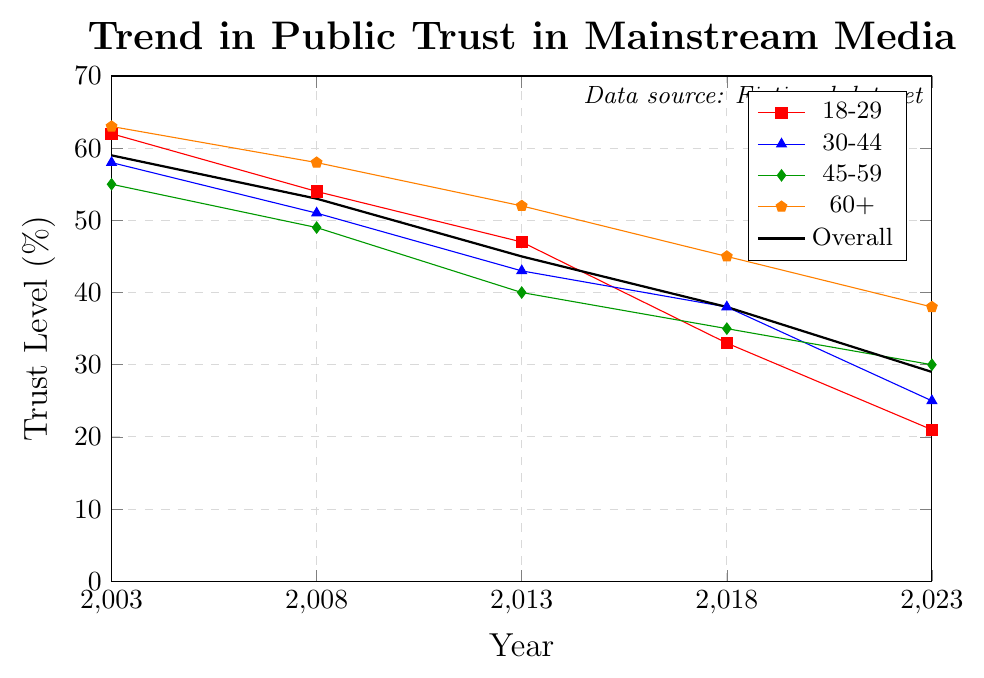What's the trend in public trust in mainstream media among the 18-29 age group over the past two decades? From the figure, we see the trust level for the 18-29 age group. It starts at 62% in 2003, drops to 54% in 2008, further to 47% in 2013, then to 33% in 2018, and finally to 21% in 2023. Thus, the trend is a consistent decrease.
Answer: Consistent decrease Which age group maintains the highest level of trust in 2023? By observing the end points of each line in the figure for 2023, it's evident that the 60+ age group has the highest trust level at 38%.
Answer: 60+ How does the decline in overall public trust from 2003 to 2023 compare to the decline for the 30-44 age group? To find the decline, we subtract the 2023 trust levels from the 2003 levels. For the overall group, it's 59% - 29% = 30%. For the 30-44 age group, it's 58% - 25% = 33%. Thus, the decline is greater for the 30-44 age group compared to the overall group.
Answer: 33% (greater decline) Between which consecutive years does the 45-59 age group see the steepest decline in trust? We need to look at the differences between consecutive years: 2003-2008 is 55% - 49% = 6%, 2008-2013 is 49% - 40% = 9%, 2013-2018 is 40% - 35% = 5%, and 2018-2023 is 35% - 30% = 5%. The steepest decline is between 2008 and 2013 at 9%.
Answer: 2008-2013 What's the average trust level in 2003 across all age groups? To find the average, sum the 2003 trust levels across all age groups (18-29: 62%, 30-44: 58%, 45-59: 55%, 60+: 63%) and divide by 4: (62+58+55+63)/4 = 59.5%.
Answer: 59.5% Which year shows the smallest difference in trust levels between the 18-29 and 60+ age groups? Calculate the differences for each year: 2003 (63-62)=1%, 2008 (58-54)=4%, 2013 (52-47)=5%, 2018 (45-33)=12%, 2023 (38-21)=17%. The smallest difference is in 2003 at 1%.
Answer: 2003 Visualize the trust levels for the 30-44 age group. What is the color and marker shape of this line in the figure? The 30-44 age group is represented by the blue line with triangle markers as indicated by the legend.
Answer: Blue, triangle markers What's the combined percentage drop for the 18-29 and 60+ age groups from 2013 to 2023? Calculate the drop for each group: 18-29 is 47% - 21% = 26% and 60+ is 52% - 38% = 14%. The combined drop is 26% + 14% = 40%.
Answer: 40% Compare the overall trust levels in 2008 and 2018. In 2008, the overall trust level is 53%, and in 2018 it is 38%. The decline can be calculated as 53% - 38% = 15%.
Answer: 15% How does the decline in trust for the 18-29 and 60+ age groups from 2003 to 2023 influence the overall trend? The 18-29 group declines from 62% to 21% (41% decrease), and the 60+ group declines from 63% to 38% (25% decrease). Significant declines in these two groups contribute noticeably to the overall downward trend, affirming the broader erosion of trust across all ages.
Answer: Significant influence 